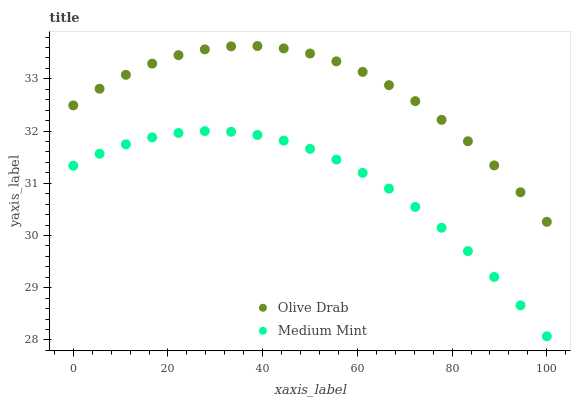Does Medium Mint have the minimum area under the curve?
Answer yes or no. Yes. Does Olive Drab have the maximum area under the curve?
Answer yes or no. Yes. Does Olive Drab have the minimum area under the curve?
Answer yes or no. No. Is Medium Mint the smoothest?
Answer yes or no. Yes. Is Olive Drab the roughest?
Answer yes or no. Yes. Is Olive Drab the smoothest?
Answer yes or no. No. Does Medium Mint have the lowest value?
Answer yes or no. Yes. Does Olive Drab have the lowest value?
Answer yes or no. No. Does Olive Drab have the highest value?
Answer yes or no. Yes. Is Medium Mint less than Olive Drab?
Answer yes or no. Yes. Is Olive Drab greater than Medium Mint?
Answer yes or no. Yes. Does Medium Mint intersect Olive Drab?
Answer yes or no. No. 